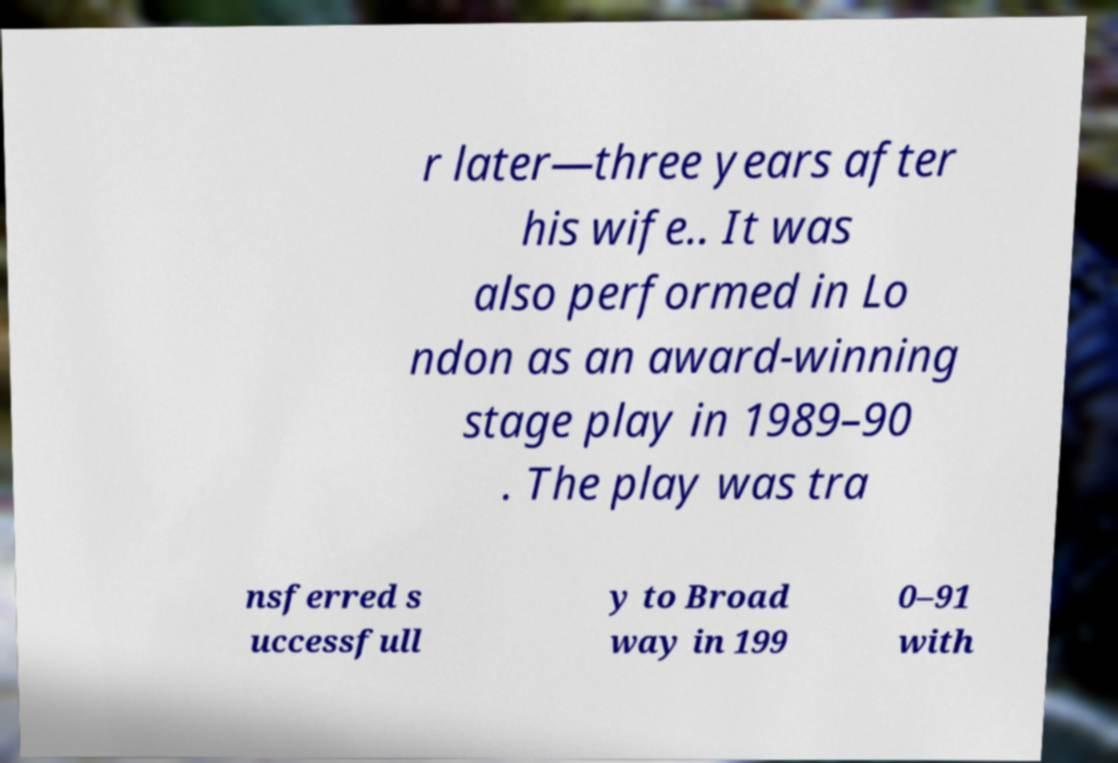Could you extract and type out the text from this image? r later—three years after his wife.. It was also performed in Lo ndon as an award-winning stage play in 1989–90 . The play was tra nsferred s uccessfull y to Broad way in 199 0–91 with 